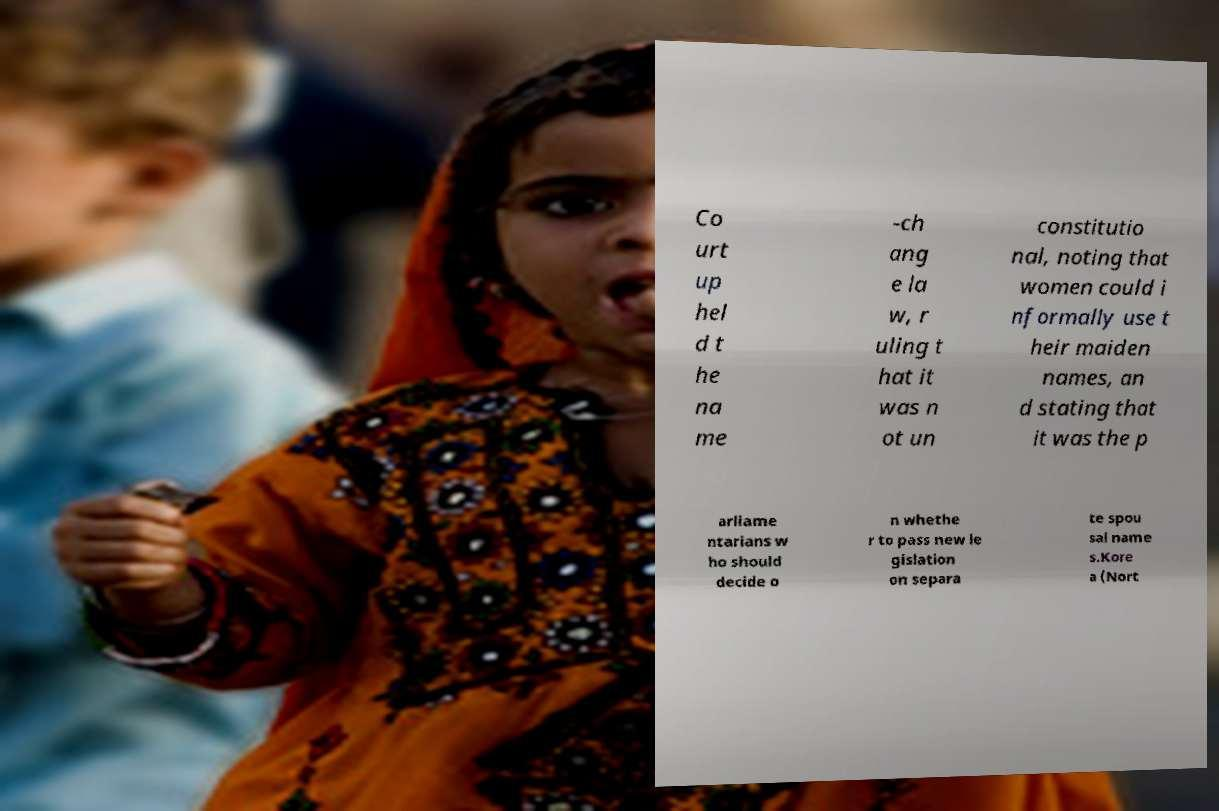Could you assist in decoding the text presented in this image and type it out clearly? Co urt up hel d t he na me -ch ang e la w, r uling t hat it was n ot un constitutio nal, noting that women could i nformally use t heir maiden names, an d stating that it was the p arliame ntarians w ho should decide o n whethe r to pass new le gislation on separa te spou sal name s.Kore a (Nort 